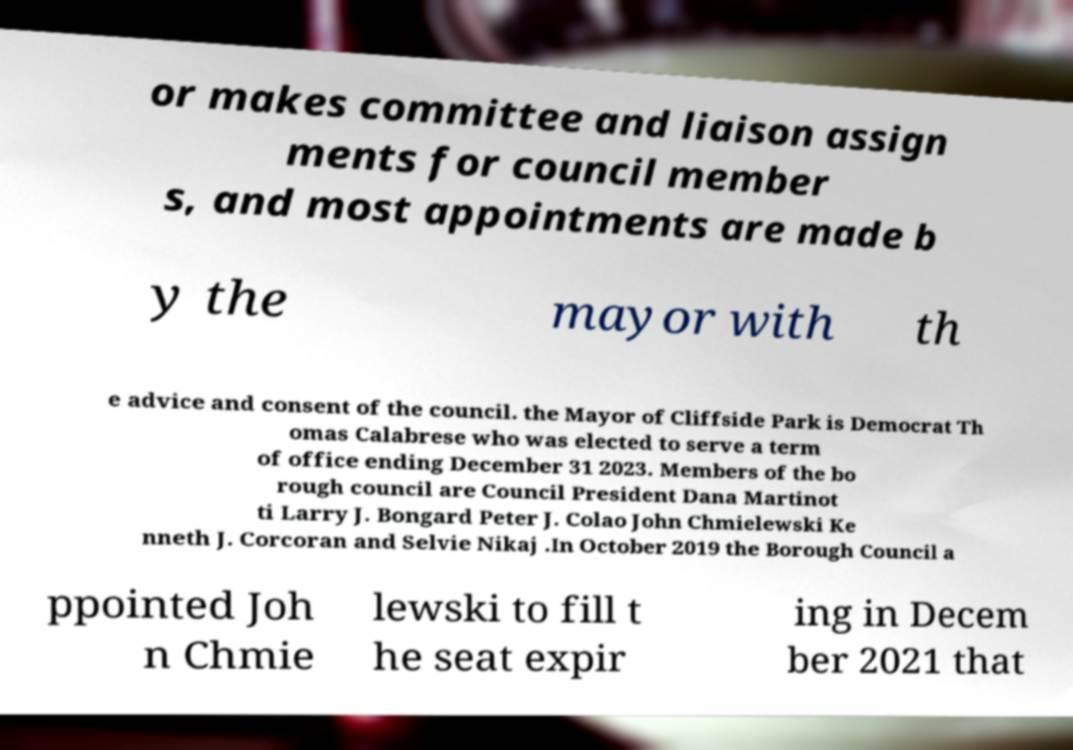Please read and relay the text visible in this image. What does it say? or makes committee and liaison assign ments for council member s, and most appointments are made b y the mayor with th e advice and consent of the council. the Mayor of Cliffside Park is Democrat Th omas Calabrese who was elected to serve a term of office ending December 31 2023. Members of the bo rough council are Council President Dana Martinot ti Larry J. Bongard Peter J. Colao John Chmielewski Ke nneth J. Corcoran and Selvie Nikaj .In October 2019 the Borough Council a ppointed Joh n Chmie lewski to fill t he seat expir ing in Decem ber 2021 that 